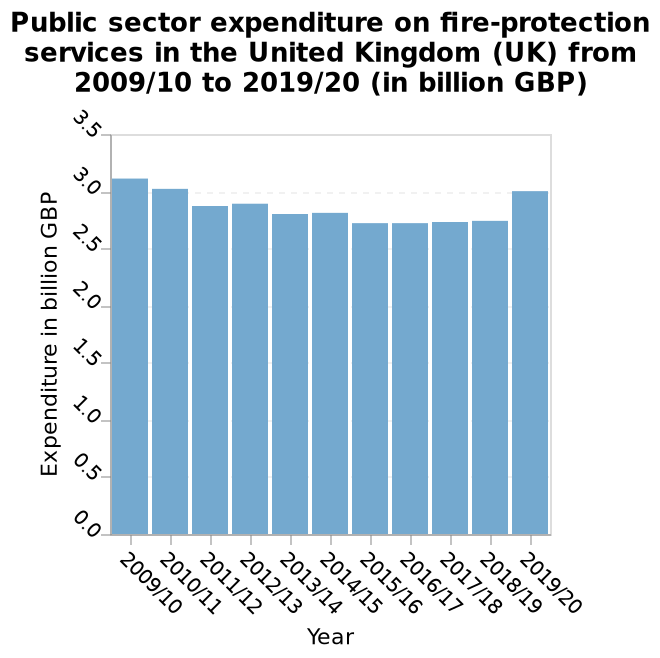<image>
Offer a thorough analysis of the image. The amount spent on fire protection in the UK has fluctuated very little in the time frame covered. What is the lowest expenditure on fire-protection services in the given time period? The lowest expenditure on fire-protection services in the given time period is 0.0 billion GBP. Describe the following image in detail Public sector expenditure on fire-protection services in the United Kingdom (UK) from 2009/10 to 2019/20 (in billion GBP) is a bar plot. There is a categorical scale from 2009/10 to 2019/20 on the x-axis, marked Year. A linear scale with a minimum of 0.0 and a maximum of 3.5 can be seen on the y-axis, labeled Expenditure in billion GBP. What is the label of the x-axis in the bar plot? The label of the x-axis in the bar plot is "Year." What is the range of the y-axis in the bar plot? The range of the y-axis in the bar plot is from 0.0 to 3.5 billion GBP. How does the fire protection level in 2019/2020 compare to 2009?  The fire protection level in 2019/2020 was indescribable, whereas it was at 2009 levels. 